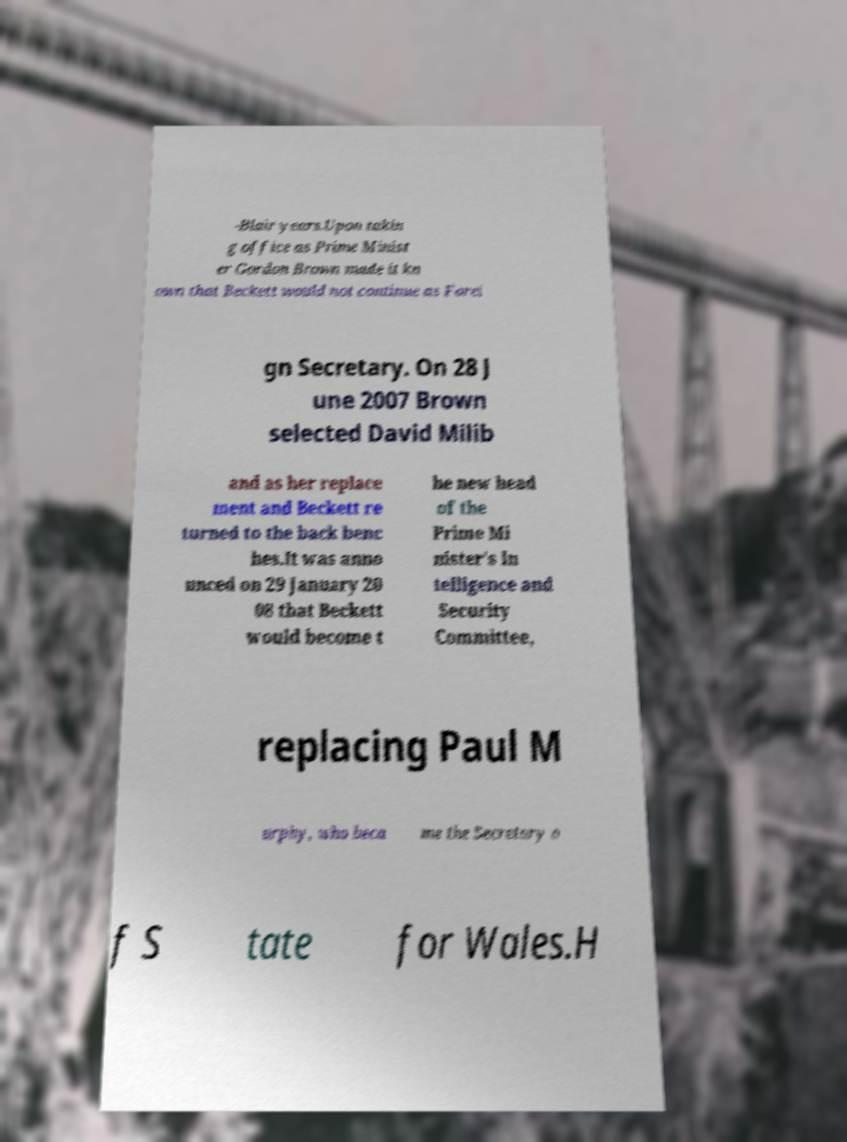What messages or text are displayed in this image? I need them in a readable, typed format. -Blair years.Upon takin g office as Prime Minist er Gordon Brown made it kn own that Beckett would not continue as Forei gn Secretary. On 28 J une 2007 Brown selected David Milib and as her replace ment and Beckett re turned to the back benc hes.It was anno unced on 29 January 20 08 that Beckett would become t he new head of the Prime Mi nister's In telligence and Security Committee, replacing Paul M urphy, who beca me the Secretary o f S tate for Wales.H 